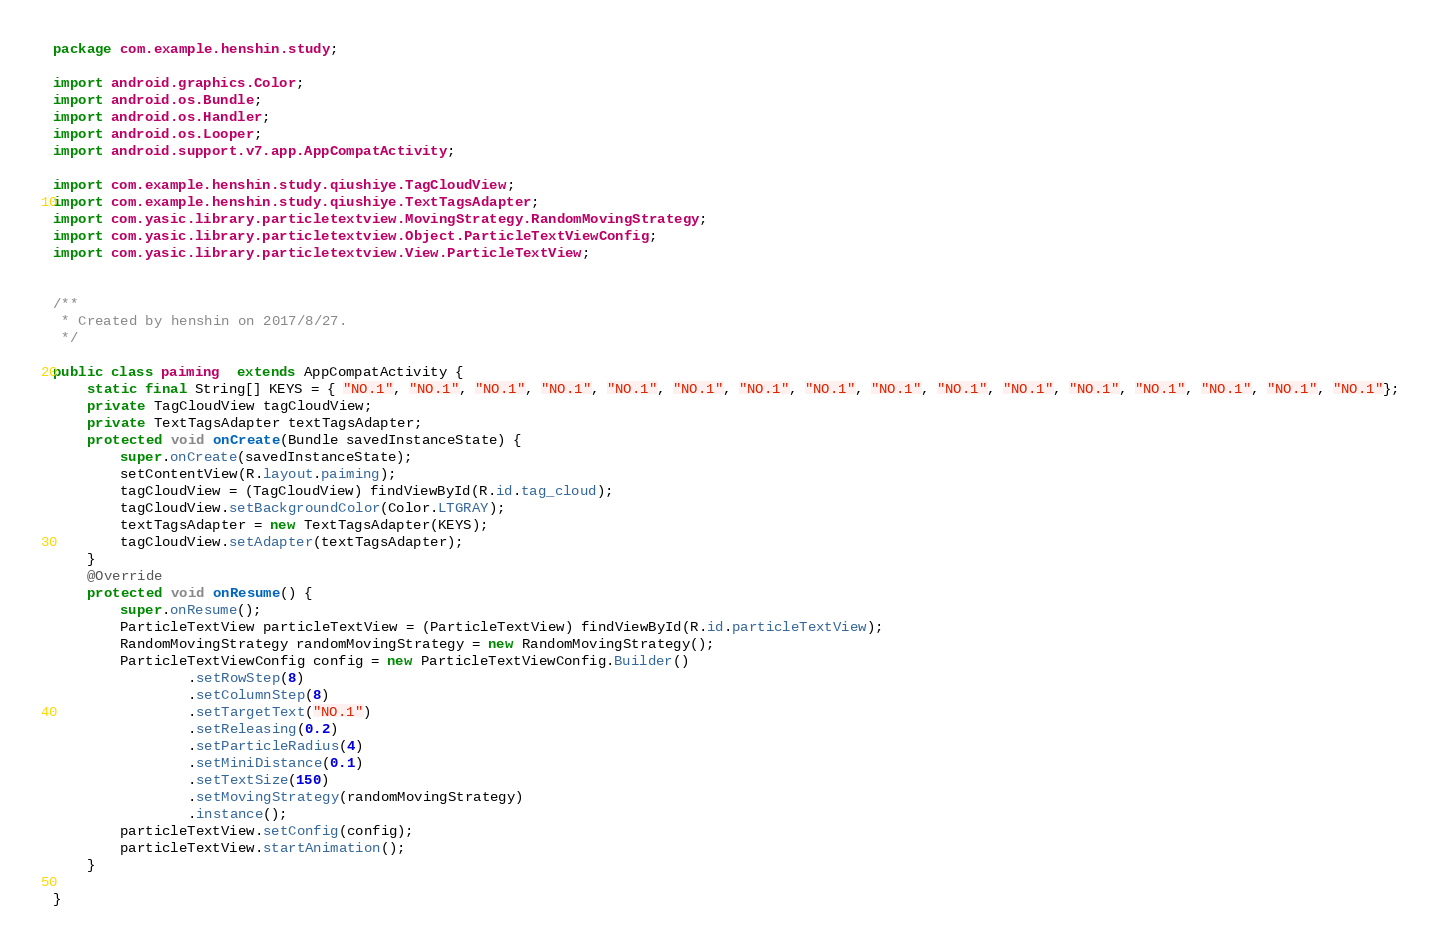<code> <loc_0><loc_0><loc_500><loc_500><_Java_>package com.example.henshin.study;

import android.graphics.Color;
import android.os.Bundle;
import android.os.Handler;
import android.os.Looper;
import android.support.v7.app.AppCompatActivity;

import com.example.henshin.study.qiushiye.TagCloudView;
import com.example.henshin.study.qiushiye.TextTagsAdapter;
import com.yasic.library.particletextview.MovingStrategy.RandomMovingStrategy;
import com.yasic.library.particletextview.Object.ParticleTextViewConfig;
import com.yasic.library.particletextview.View.ParticleTextView;


/**
 * Created by henshin on 2017/8/27.
 */

public class paiming  extends AppCompatActivity {
    static final String[] KEYS = { "NO.1", "NO.1", "NO.1", "NO.1", "NO.1", "NO.1", "NO.1", "NO.1", "NO.1", "NO.1", "NO.1", "NO.1", "NO.1", "NO.1", "NO.1", "NO.1"};
    private TagCloudView tagCloudView;
    private TextTagsAdapter textTagsAdapter;
    protected void onCreate(Bundle savedInstanceState) {
        super.onCreate(savedInstanceState);
        setContentView(R.layout.paiming);
        tagCloudView = (TagCloudView) findViewById(R.id.tag_cloud);
        tagCloudView.setBackgroundColor(Color.LTGRAY);
        textTagsAdapter = new TextTagsAdapter(KEYS);
        tagCloudView.setAdapter(textTagsAdapter);
    }
    @Override
    protected void onResume() {
        super.onResume();
        ParticleTextView particleTextView = (ParticleTextView) findViewById(R.id.particleTextView);
        RandomMovingStrategy randomMovingStrategy = new RandomMovingStrategy();
        ParticleTextViewConfig config = new ParticleTextViewConfig.Builder()
                .setRowStep(8)
                .setColumnStep(8)
                .setTargetText("NO.1")
                .setReleasing(0.2)
                .setParticleRadius(4)
                .setMiniDistance(0.1)
                .setTextSize(150)
                .setMovingStrategy(randomMovingStrategy)
                .instance();
        particleTextView.setConfig(config);
        particleTextView.startAnimation();
    }

}
</code> 